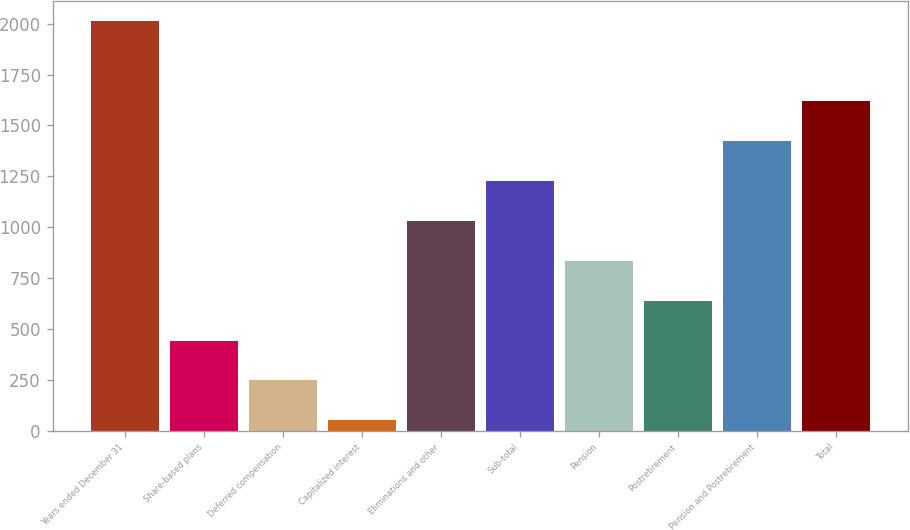Convert chart to OTSL. <chart><loc_0><loc_0><loc_500><loc_500><bar_chart><fcel>Years ended December 31<fcel>Share-based plans<fcel>Deferred compensation<fcel>Capitalized interest<fcel>Eliminations and other<fcel>Sub-total<fcel>Pension<fcel>Postretirement<fcel>Pension and Postretirement<fcel>Total<nl><fcel>2011<fcel>443<fcel>247<fcel>51<fcel>1031<fcel>1227<fcel>835<fcel>639<fcel>1423<fcel>1619<nl></chart> 